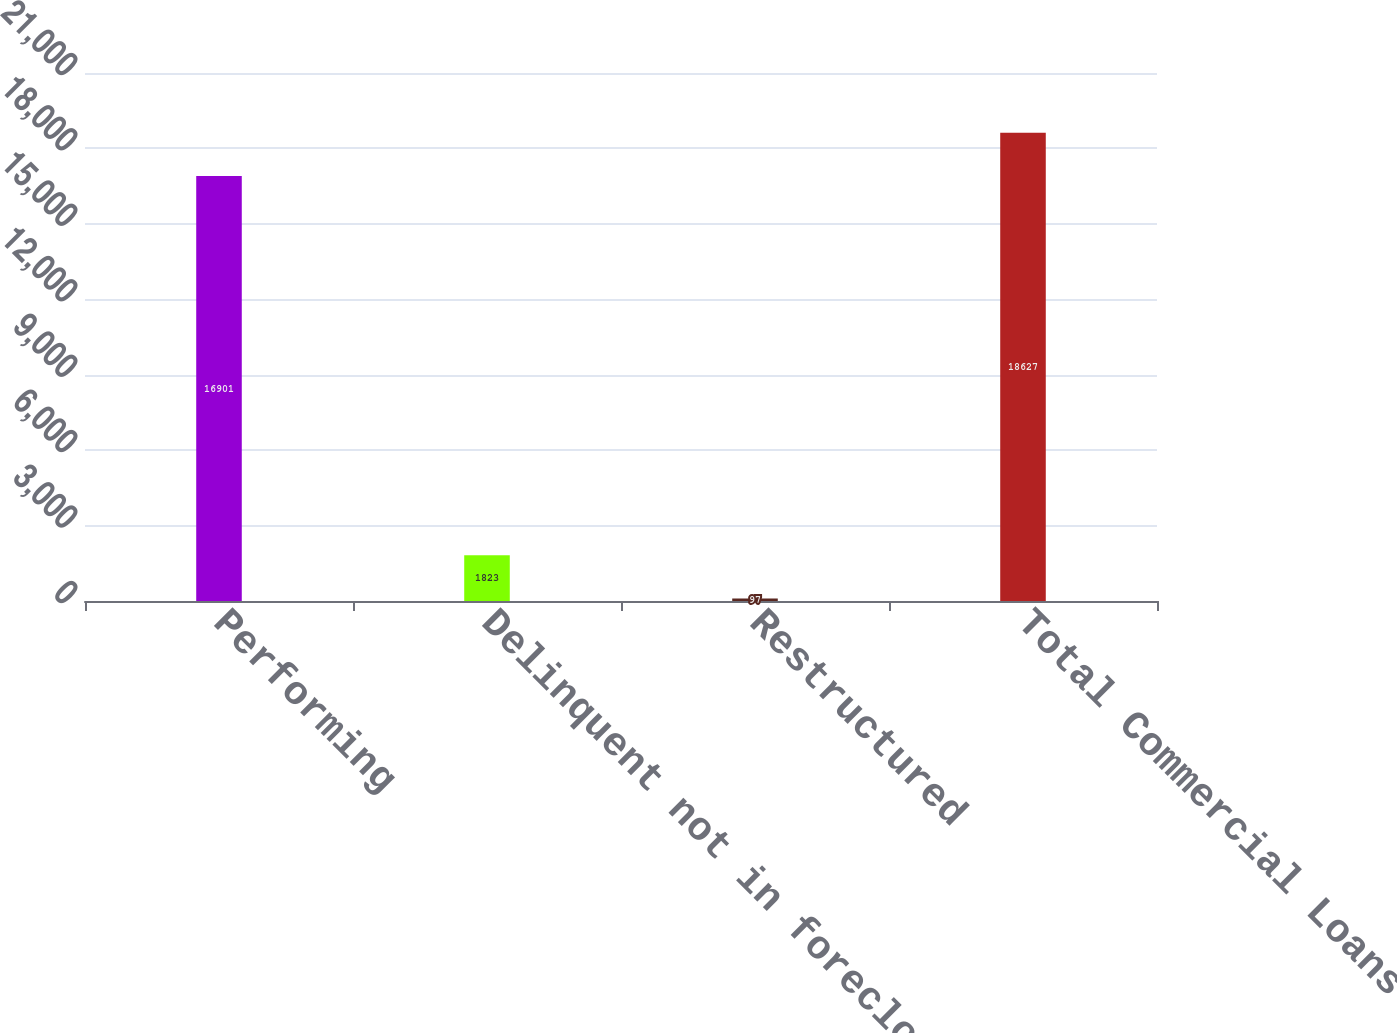<chart> <loc_0><loc_0><loc_500><loc_500><bar_chart><fcel>Performing<fcel>Delinquent not in foreclosure<fcel>Restructured<fcel>Total Commercial Loans<nl><fcel>16901<fcel>1823<fcel>97<fcel>18627<nl></chart> 